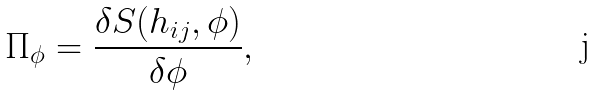Convert formula to latex. <formula><loc_0><loc_0><loc_500><loc_500>\Pi _ { \phi } = \frac { \delta S ( h _ { i j } , \phi ) } { \delta \phi } ,</formula> 